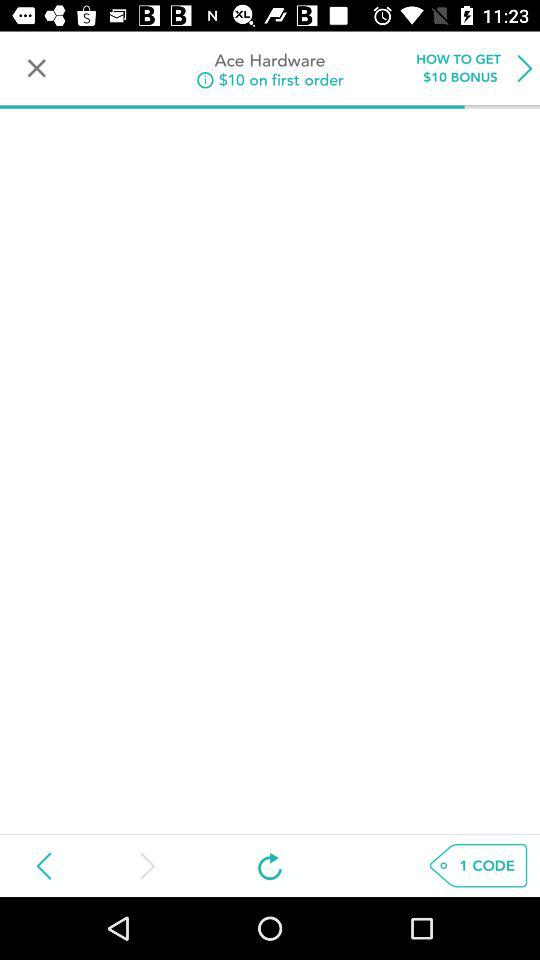How many codes are there? There is 1 code. 